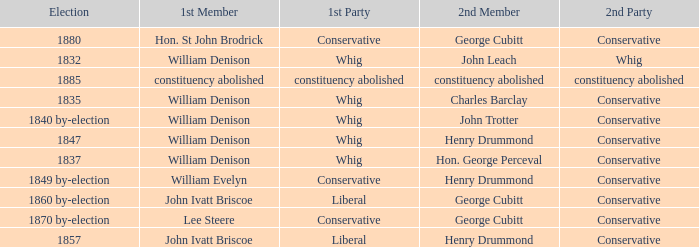Which party's 1st member is John Ivatt Briscoe in an election in 1857? Liberal. 